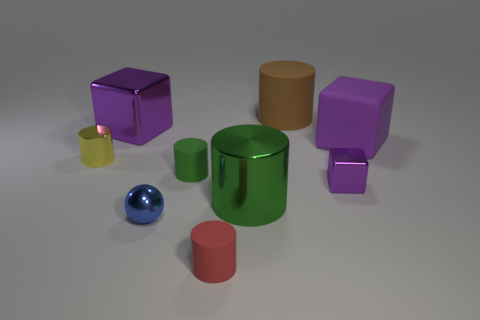What number of tiny green matte objects have the same shape as the tiny yellow metal object?
Offer a very short reply. 1. Is the number of tiny purple things that are to the left of the tiny red cylinder the same as the number of blue metallic things?
Offer a very short reply. No. There is another rubber object that is the same size as the brown rubber object; what color is it?
Keep it short and to the point. Purple. Are there any small red objects of the same shape as the tiny green matte thing?
Keep it short and to the point. Yes. What material is the cylinder in front of the green object that is on the right side of the tiny red matte cylinder that is on the left side of the big green shiny cylinder?
Keep it short and to the point. Rubber. Is the number of gray cylinders the same as the number of small cylinders?
Give a very brief answer. No. How many other things are there of the same size as the blue object?
Provide a succinct answer. 4. What is the color of the big matte cylinder?
Make the answer very short. Brown. How many shiny objects are green cylinders or tiny brown blocks?
Provide a succinct answer. 1. Is there any other thing that has the same material as the brown thing?
Provide a succinct answer. Yes. 